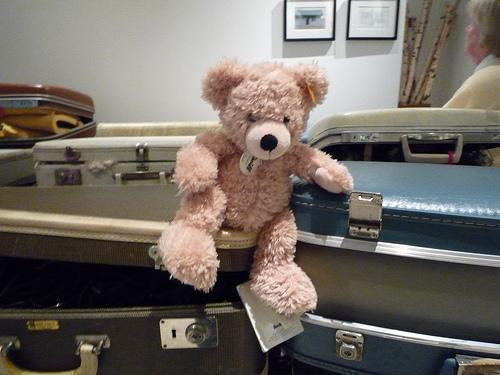How many suitcases are pictured?
Give a very brief answer. 5. How many people are in this picture?
Give a very brief answer. 1. How many pictures are on the wall?
Give a very brief answer. 2. 